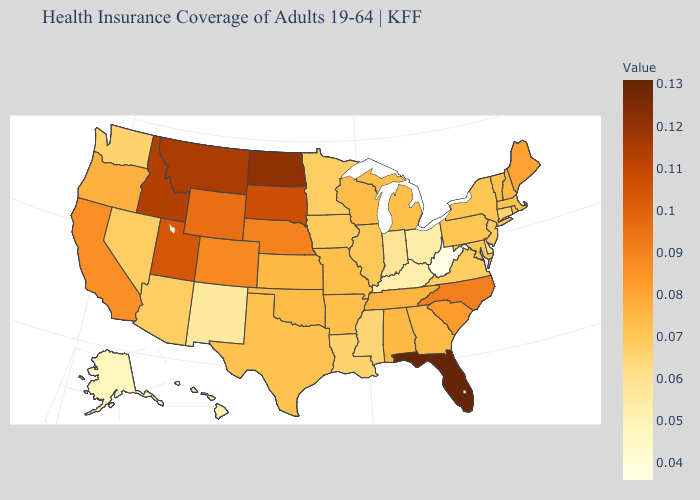Does Arizona have the highest value in the West?
Concise answer only. No. Which states have the highest value in the USA?
Concise answer only. Florida. Which states hav the highest value in the West?
Write a very short answer. Montana. Which states have the highest value in the USA?
Short answer required. Florida. Does Rhode Island have a lower value than California?
Write a very short answer. Yes. Does Hawaii have the highest value in the West?
Quick response, please. No. Is the legend a continuous bar?
Concise answer only. Yes. Does South Dakota have the highest value in the USA?
Quick response, please. No. 